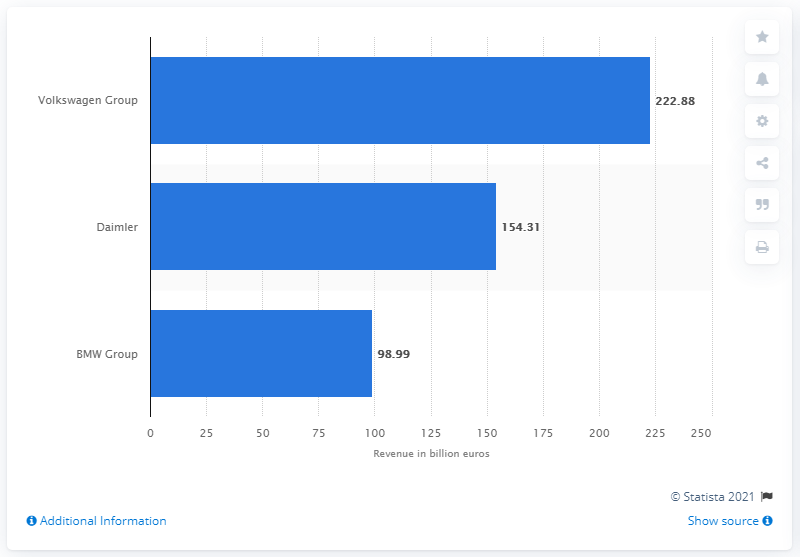Highlight a few significant elements in this photo. The Volkswagen Group is the largest auto manufacturing group based in Germany. The Volkswagen Group is the largest auto manufacturing group based in Germany. In 2020, Volkswagen generated a total revenue of 222.88 million dollars. 